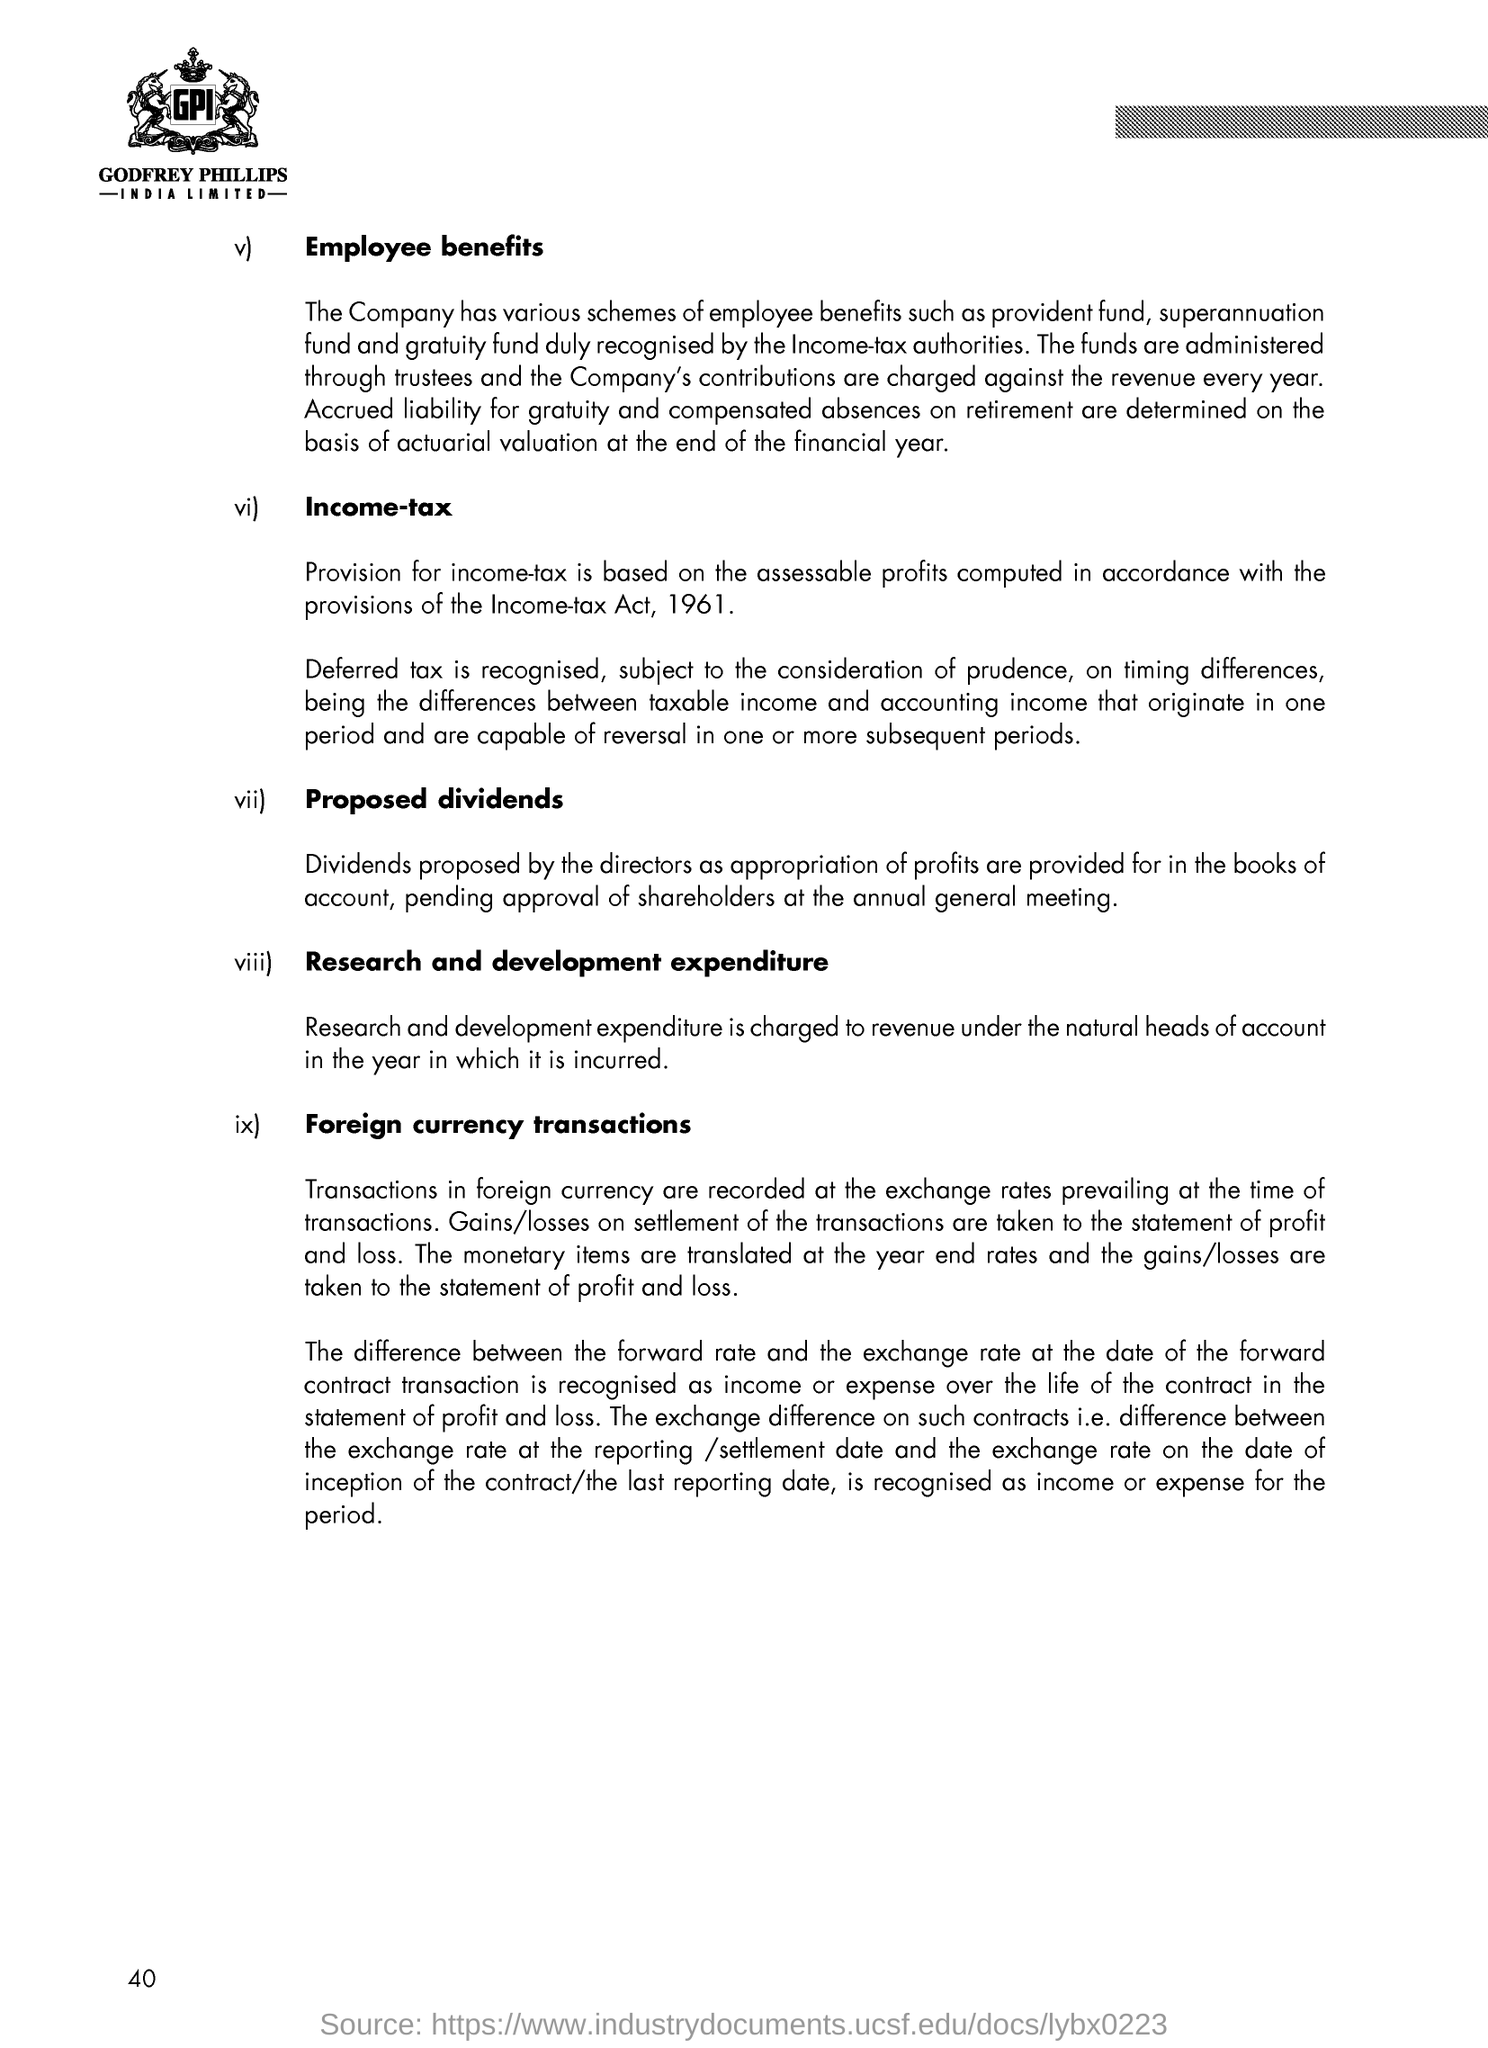Mention the three letter word shown inside the logo on the top of the document? The three-letter word displayed inside the logo at the top of the document is 'GPI'. This acronym likely stands for the company name 'Godfrey Phillips India Limited', which is also the full name printed below the logo. The company appears to be disclosing financial and policy information, possibly in an annual report or similar corporate document. 